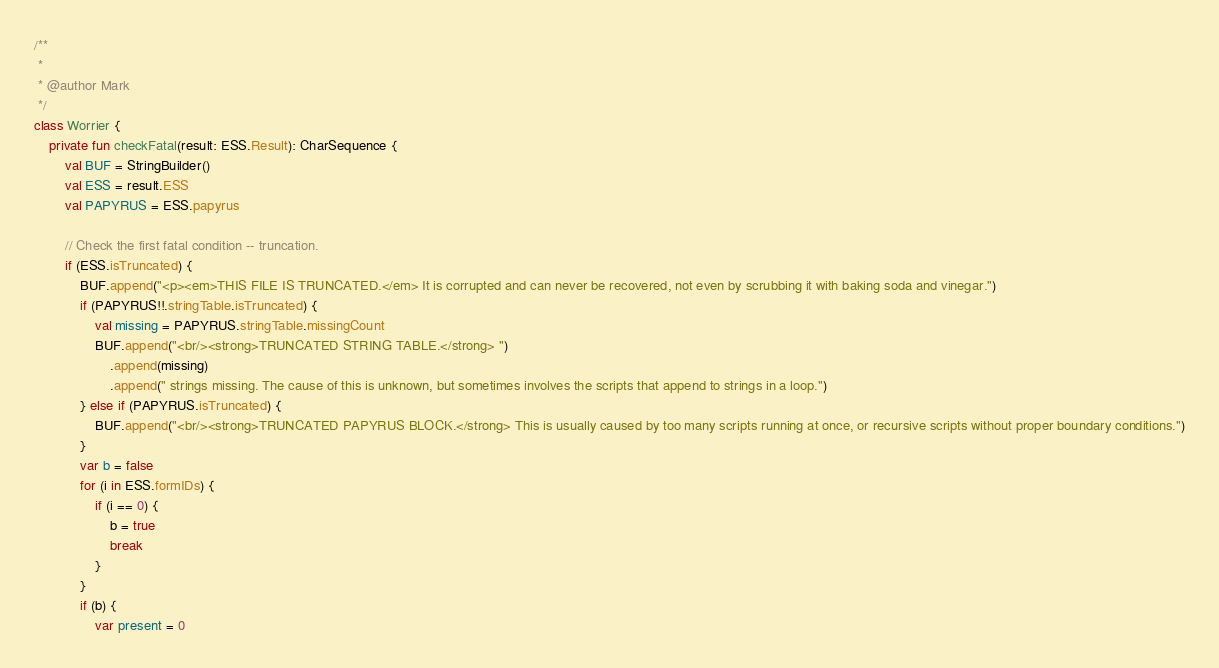<code> <loc_0><loc_0><loc_500><loc_500><_Kotlin_>/**
 *
 * @author Mark
 */
class Worrier {
    private fun checkFatal(result: ESS.Result): CharSequence {
        val BUF = StringBuilder()
        val ESS = result.ESS
        val PAPYRUS = ESS.papyrus

        // Check the first fatal condition -- truncation.
        if (ESS.isTruncated) {
            BUF.append("<p><em>THIS FILE IS TRUNCATED.</em> It is corrupted and can never be recovered, not even by scrubbing it with baking soda and vinegar.")
            if (PAPYRUS!!.stringTable.isTruncated) {
                val missing = PAPYRUS.stringTable.missingCount
                BUF.append("<br/><strong>TRUNCATED STRING TABLE.</strong> ")
                    .append(missing)
                    .append(" strings missing. The cause of this is unknown, but sometimes involves the scripts that append to strings in a loop.")
            } else if (PAPYRUS.isTruncated) {
                BUF.append("<br/><strong>TRUNCATED PAPYRUS BLOCK.</strong> This is usually caused by too many scripts running at once, or recursive scripts without proper boundary conditions.")
            }
            var b = false
            for (i in ESS.formIDs) {
                if (i == 0) {
                    b = true
                    break
                }
            }
            if (b) {
                var present = 0</code> 